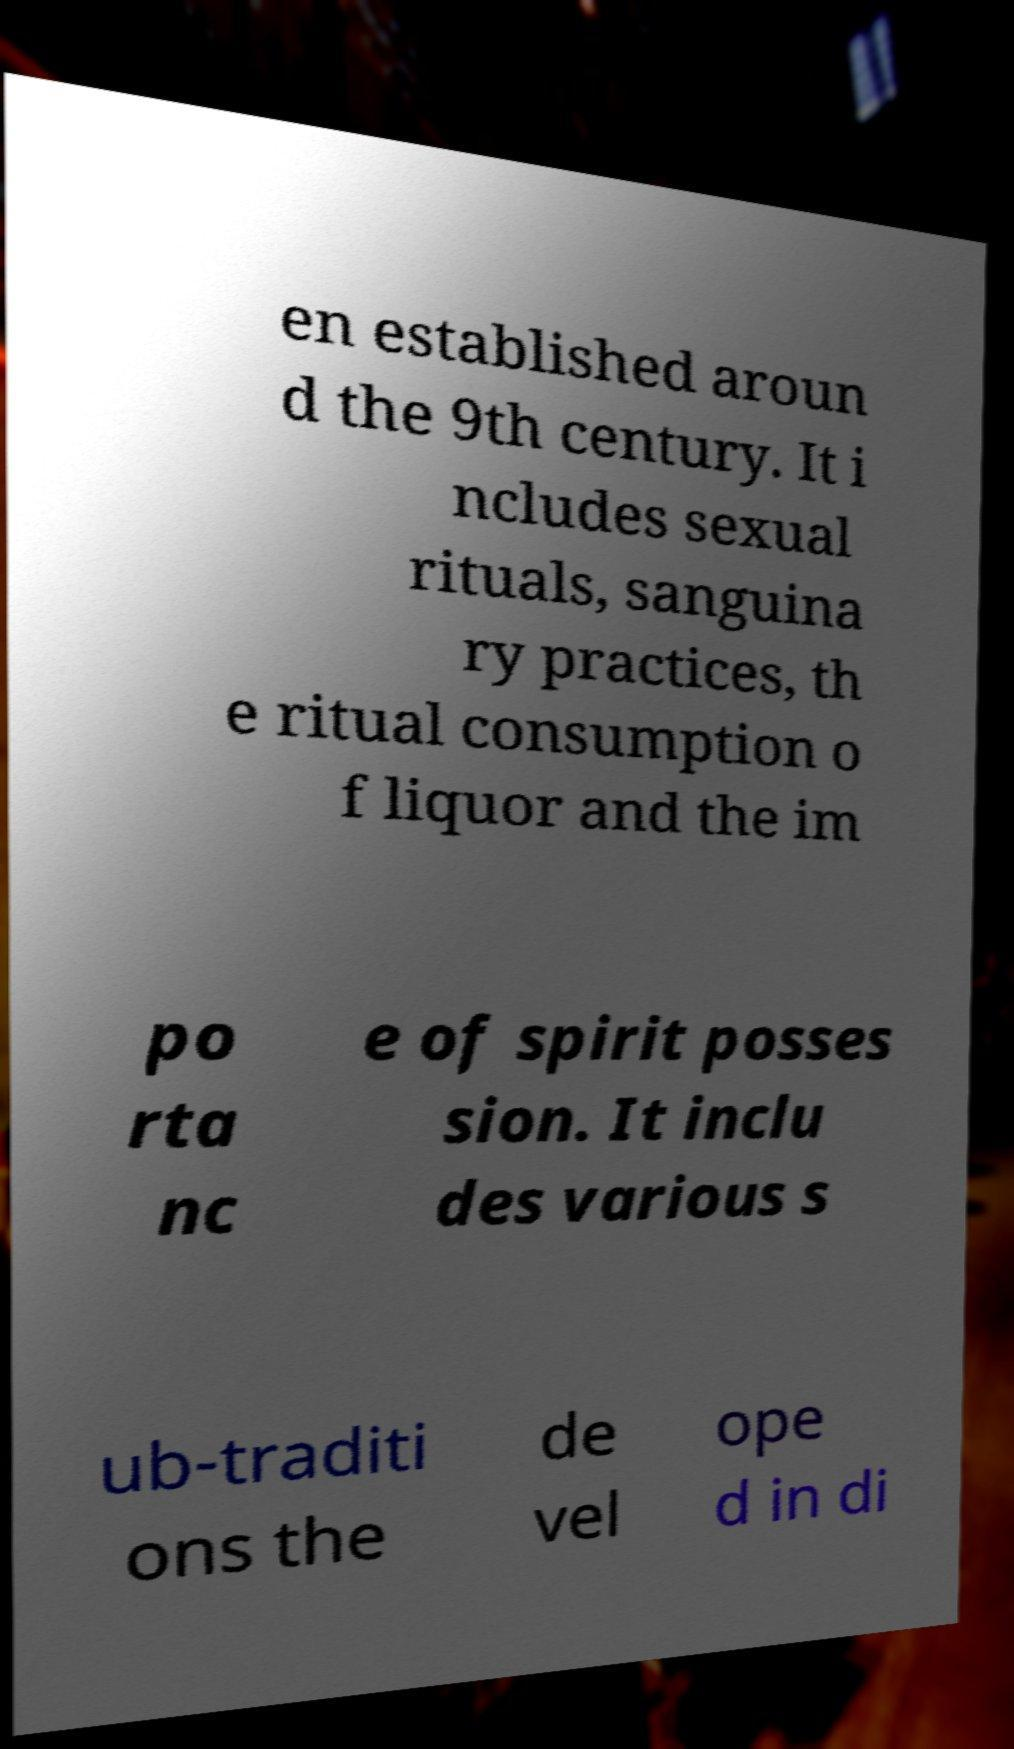I need the written content from this picture converted into text. Can you do that? en established aroun d the 9th century. It i ncludes sexual rituals, sanguina ry practices, th e ritual consumption o f liquor and the im po rta nc e of spirit posses sion. It inclu des various s ub-traditi ons the de vel ope d in di 